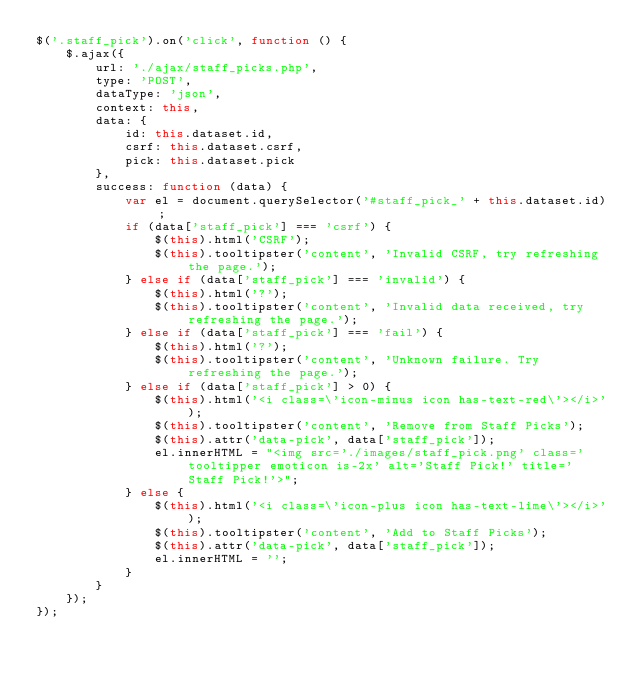<code> <loc_0><loc_0><loc_500><loc_500><_JavaScript_>$('.staff_pick').on('click', function () {
    $.ajax({
        url: './ajax/staff_picks.php',
        type: 'POST',
        dataType: 'json',
        context: this,
        data: {
            id: this.dataset.id,
            csrf: this.dataset.csrf,
            pick: this.dataset.pick
        },
        success: function (data) {
            var el = document.querySelector('#staff_pick_' + this.dataset.id);
            if (data['staff_pick'] === 'csrf') {
                $(this).html('CSRF');
                $(this).tooltipster('content', 'Invalid CSRF, try refreshing the page.');
            } else if (data['staff_pick'] === 'invalid') {
                $(this).html('?');
                $(this).tooltipster('content', 'Invalid data received, try refreshing the page.');
            } else if (data['staff_pick'] === 'fail') {
                $(this).html('?');
                $(this).tooltipster('content', 'Unknown failure. Try refreshing the page.');
            } else if (data['staff_pick'] > 0) {
                $(this).html('<i class=\'icon-minus icon has-text-red\'></i>');
                $(this).tooltipster('content', 'Remove from Staff Picks');
                $(this).attr('data-pick', data['staff_pick']);
                el.innerHTML = "<img src='./images/staff_pick.png' class='tooltipper emoticon is-2x' alt='Staff Pick!' title='Staff Pick!'>";
            } else {
                $(this).html('<i class=\'icon-plus icon has-text-lime\'></i>');
                $(this).tooltipster('content', 'Add to Staff Picks');
                $(this).attr('data-pick', data['staff_pick']);
                el.innerHTML = '';
            }
        }
    });
});
</code> 